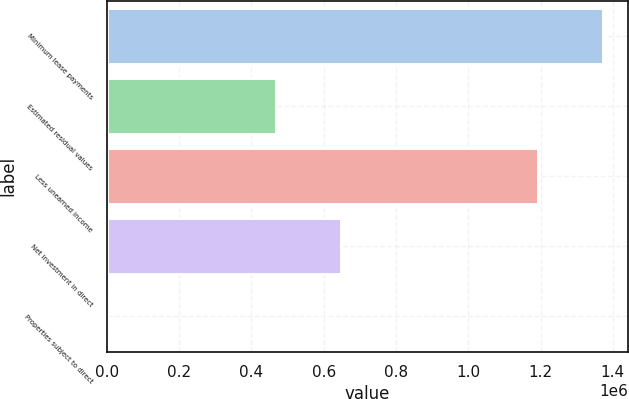Convert chart. <chart><loc_0><loc_0><loc_500><loc_500><bar_chart><fcel>Minimum lease payments<fcel>Estimated residual values<fcel>Less unearned income<fcel>Net investment in direct<fcel>Properties subject to direct<nl><fcel>1.37328e+06<fcel>467248<fcel>1.1923e+06<fcel>648234<fcel>30<nl></chart> 